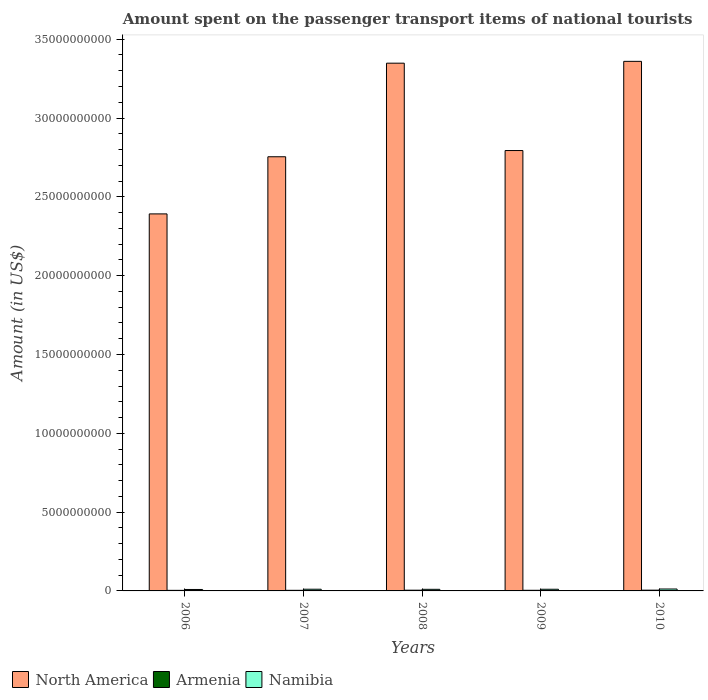How many groups of bars are there?
Provide a short and direct response. 5. Are the number of bars per tick equal to the number of legend labels?
Ensure brevity in your answer.  Yes. What is the amount spent on the passenger transport items of national tourists in Armenia in 2007?
Ensure brevity in your answer.  3.80e+07. Across all years, what is the maximum amount spent on the passenger transport items of national tourists in North America?
Your response must be concise. 3.36e+1. Across all years, what is the minimum amount spent on the passenger transport items of national tourists in Namibia?
Your answer should be compact. 9.20e+07. In which year was the amount spent on the passenger transport items of national tourists in North America maximum?
Your answer should be very brief. 2010. In which year was the amount spent on the passenger transport items of national tourists in Armenia minimum?
Ensure brevity in your answer.  2006. What is the total amount spent on the passenger transport items of national tourists in Armenia in the graph?
Your response must be concise. 2.08e+08. What is the difference between the amount spent on the passenger transport items of national tourists in Namibia in 2007 and that in 2008?
Provide a short and direct response. 6.00e+06. What is the difference between the amount spent on the passenger transport items of national tourists in Armenia in 2008 and the amount spent on the passenger transport items of national tourists in North America in 2010?
Ensure brevity in your answer.  -3.36e+1. What is the average amount spent on the passenger transport items of national tourists in Armenia per year?
Ensure brevity in your answer.  4.16e+07. In the year 2006, what is the difference between the amount spent on the passenger transport items of national tourists in North America and amount spent on the passenger transport items of national tourists in Armenia?
Give a very brief answer. 2.39e+1. In how many years, is the amount spent on the passenger transport items of national tourists in Armenia greater than 6000000000 US$?
Offer a terse response. 0. What is the ratio of the amount spent on the passenger transport items of national tourists in Armenia in 2008 to that in 2009?
Your answer should be compact. 1.15. Is the amount spent on the passenger transport items of national tourists in Armenia in 2006 less than that in 2009?
Keep it short and to the point. Yes. Is the difference between the amount spent on the passenger transport items of national tourists in North America in 2008 and 2009 greater than the difference between the amount spent on the passenger transport items of national tourists in Armenia in 2008 and 2009?
Your response must be concise. Yes. What is the difference between the highest and the second highest amount spent on the passenger transport items of national tourists in Armenia?
Offer a very short reply. 2.00e+06. What is the difference between the highest and the lowest amount spent on the passenger transport items of national tourists in North America?
Provide a short and direct response. 9.68e+09. In how many years, is the amount spent on the passenger transport items of national tourists in Namibia greater than the average amount spent on the passenger transport items of national tourists in Namibia taken over all years?
Your answer should be compact. 3. What does the 2nd bar from the left in 2008 represents?
Make the answer very short. Armenia. What does the 1st bar from the right in 2006 represents?
Give a very brief answer. Namibia. Is it the case that in every year, the sum of the amount spent on the passenger transport items of national tourists in Namibia and amount spent on the passenger transport items of national tourists in North America is greater than the amount spent on the passenger transport items of national tourists in Armenia?
Offer a very short reply. Yes. How many years are there in the graph?
Your answer should be compact. 5. Does the graph contain any zero values?
Your response must be concise. No. Where does the legend appear in the graph?
Give a very brief answer. Bottom left. How are the legend labels stacked?
Give a very brief answer. Horizontal. What is the title of the graph?
Your answer should be compact. Amount spent on the passenger transport items of national tourists. Does "Hong Kong" appear as one of the legend labels in the graph?
Your answer should be very brief. No. What is the label or title of the X-axis?
Offer a terse response. Years. What is the Amount (in US$) in North America in 2006?
Provide a short and direct response. 2.39e+1. What is the Amount (in US$) of Armenia in 2006?
Your response must be concise. 3.60e+07. What is the Amount (in US$) of Namibia in 2006?
Your response must be concise. 9.20e+07. What is the Amount (in US$) in North America in 2007?
Offer a terse response. 2.75e+1. What is the Amount (in US$) in Armenia in 2007?
Make the answer very short. 3.80e+07. What is the Amount (in US$) in Namibia in 2007?
Provide a succinct answer. 1.08e+08. What is the Amount (in US$) in North America in 2008?
Your answer should be compact. 3.35e+1. What is the Amount (in US$) in Armenia in 2008?
Your response must be concise. 4.60e+07. What is the Amount (in US$) in Namibia in 2008?
Offer a very short reply. 1.02e+08. What is the Amount (in US$) in North America in 2009?
Your answer should be very brief. 2.79e+1. What is the Amount (in US$) of Armenia in 2009?
Make the answer very short. 4.00e+07. What is the Amount (in US$) of Namibia in 2009?
Keep it short and to the point. 1.06e+08. What is the Amount (in US$) in North America in 2010?
Your answer should be compact. 3.36e+1. What is the Amount (in US$) of Armenia in 2010?
Make the answer very short. 4.80e+07. What is the Amount (in US$) in Namibia in 2010?
Your answer should be very brief. 1.21e+08. Across all years, what is the maximum Amount (in US$) of North America?
Your answer should be very brief. 3.36e+1. Across all years, what is the maximum Amount (in US$) in Armenia?
Your answer should be compact. 4.80e+07. Across all years, what is the maximum Amount (in US$) in Namibia?
Your answer should be very brief. 1.21e+08. Across all years, what is the minimum Amount (in US$) of North America?
Give a very brief answer. 2.39e+1. Across all years, what is the minimum Amount (in US$) of Armenia?
Your answer should be very brief. 3.60e+07. Across all years, what is the minimum Amount (in US$) of Namibia?
Your response must be concise. 9.20e+07. What is the total Amount (in US$) in North America in the graph?
Ensure brevity in your answer.  1.46e+11. What is the total Amount (in US$) in Armenia in the graph?
Provide a succinct answer. 2.08e+08. What is the total Amount (in US$) in Namibia in the graph?
Keep it short and to the point. 5.29e+08. What is the difference between the Amount (in US$) in North America in 2006 and that in 2007?
Your answer should be compact. -3.63e+09. What is the difference between the Amount (in US$) of Armenia in 2006 and that in 2007?
Your answer should be very brief. -2.00e+06. What is the difference between the Amount (in US$) in Namibia in 2006 and that in 2007?
Your answer should be compact. -1.60e+07. What is the difference between the Amount (in US$) in North America in 2006 and that in 2008?
Offer a very short reply. -9.56e+09. What is the difference between the Amount (in US$) in Armenia in 2006 and that in 2008?
Offer a very short reply. -1.00e+07. What is the difference between the Amount (in US$) in Namibia in 2006 and that in 2008?
Give a very brief answer. -1.00e+07. What is the difference between the Amount (in US$) in North America in 2006 and that in 2009?
Keep it short and to the point. -4.02e+09. What is the difference between the Amount (in US$) of Namibia in 2006 and that in 2009?
Provide a short and direct response. -1.40e+07. What is the difference between the Amount (in US$) of North America in 2006 and that in 2010?
Offer a very short reply. -9.68e+09. What is the difference between the Amount (in US$) in Armenia in 2006 and that in 2010?
Your answer should be very brief. -1.20e+07. What is the difference between the Amount (in US$) in Namibia in 2006 and that in 2010?
Give a very brief answer. -2.90e+07. What is the difference between the Amount (in US$) in North America in 2007 and that in 2008?
Keep it short and to the point. -5.94e+09. What is the difference between the Amount (in US$) of Armenia in 2007 and that in 2008?
Your answer should be compact. -8.00e+06. What is the difference between the Amount (in US$) of North America in 2007 and that in 2009?
Your answer should be very brief. -3.94e+08. What is the difference between the Amount (in US$) of Namibia in 2007 and that in 2009?
Provide a short and direct response. 2.00e+06. What is the difference between the Amount (in US$) in North America in 2007 and that in 2010?
Provide a succinct answer. -6.05e+09. What is the difference between the Amount (in US$) in Armenia in 2007 and that in 2010?
Give a very brief answer. -1.00e+07. What is the difference between the Amount (in US$) in Namibia in 2007 and that in 2010?
Give a very brief answer. -1.30e+07. What is the difference between the Amount (in US$) of North America in 2008 and that in 2009?
Your answer should be compact. 5.54e+09. What is the difference between the Amount (in US$) in North America in 2008 and that in 2010?
Offer a very short reply. -1.16e+08. What is the difference between the Amount (in US$) in Armenia in 2008 and that in 2010?
Offer a terse response. -2.00e+06. What is the difference between the Amount (in US$) in Namibia in 2008 and that in 2010?
Your answer should be compact. -1.90e+07. What is the difference between the Amount (in US$) in North America in 2009 and that in 2010?
Provide a short and direct response. -5.66e+09. What is the difference between the Amount (in US$) in Armenia in 2009 and that in 2010?
Keep it short and to the point. -8.00e+06. What is the difference between the Amount (in US$) of Namibia in 2009 and that in 2010?
Make the answer very short. -1.50e+07. What is the difference between the Amount (in US$) of North America in 2006 and the Amount (in US$) of Armenia in 2007?
Provide a succinct answer. 2.39e+1. What is the difference between the Amount (in US$) in North America in 2006 and the Amount (in US$) in Namibia in 2007?
Make the answer very short. 2.38e+1. What is the difference between the Amount (in US$) in Armenia in 2006 and the Amount (in US$) in Namibia in 2007?
Offer a terse response. -7.20e+07. What is the difference between the Amount (in US$) in North America in 2006 and the Amount (in US$) in Armenia in 2008?
Keep it short and to the point. 2.39e+1. What is the difference between the Amount (in US$) in North America in 2006 and the Amount (in US$) in Namibia in 2008?
Make the answer very short. 2.38e+1. What is the difference between the Amount (in US$) in Armenia in 2006 and the Amount (in US$) in Namibia in 2008?
Your answer should be compact. -6.60e+07. What is the difference between the Amount (in US$) of North America in 2006 and the Amount (in US$) of Armenia in 2009?
Give a very brief answer. 2.39e+1. What is the difference between the Amount (in US$) of North America in 2006 and the Amount (in US$) of Namibia in 2009?
Ensure brevity in your answer.  2.38e+1. What is the difference between the Amount (in US$) in Armenia in 2006 and the Amount (in US$) in Namibia in 2009?
Make the answer very short. -7.00e+07. What is the difference between the Amount (in US$) in North America in 2006 and the Amount (in US$) in Armenia in 2010?
Provide a short and direct response. 2.39e+1. What is the difference between the Amount (in US$) of North America in 2006 and the Amount (in US$) of Namibia in 2010?
Give a very brief answer. 2.38e+1. What is the difference between the Amount (in US$) of Armenia in 2006 and the Amount (in US$) of Namibia in 2010?
Your response must be concise. -8.50e+07. What is the difference between the Amount (in US$) of North America in 2007 and the Amount (in US$) of Armenia in 2008?
Make the answer very short. 2.75e+1. What is the difference between the Amount (in US$) in North America in 2007 and the Amount (in US$) in Namibia in 2008?
Provide a short and direct response. 2.74e+1. What is the difference between the Amount (in US$) of Armenia in 2007 and the Amount (in US$) of Namibia in 2008?
Give a very brief answer. -6.40e+07. What is the difference between the Amount (in US$) in North America in 2007 and the Amount (in US$) in Armenia in 2009?
Offer a very short reply. 2.75e+1. What is the difference between the Amount (in US$) of North America in 2007 and the Amount (in US$) of Namibia in 2009?
Your response must be concise. 2.74e+1. What is the difference between the Amount (in US$) in Armenia in 2007 and the Amount (in US$) in Namibia in 2009?
Make the answer very short. -6.80e+07. What is the difference between the Amount (in US$) in North America in 2007 and the Amount (in US$) in Armenia in 2010?
Provide a succinct answer. 2.75e+1. What is the difference between the Amount (in US$) of North America in 2007 and the Amount (in US$) of Namibia in 2010?
Make the answer very short. 2.74e+1. What is the difference between the Amount (in US$) of Armenia in 2007 and the Amount (in US$) of Namibia in 2010?
Your answer should be very brief. -8.30e+07. What is the difference between the Amount (in US$) of North America in 2008 and the Amount (in US$) of Armenia in 2009?
Ensure brevity in your answer.  3.34e+1. What is the difference between the Amount (in US$) in North America in 2008 and the Amount (in US$) in Namibia in 2009?
Offer a terse response. 3.34e+1. What is the difference between the Amount (in US$) in Armenia in 2008 and the Amount (in US$) in Namibia in 2009?
Ensure brevity in your answer.  -6.00e+07. What is the difference between the Amount (in US$) of North America in 2008 and the Amount (in US$) of Armenia in 2010?
Offer a terse response. 3.34e+1. What is the difference between the Amount (in US$) in North America in 2008 and the Amount (in US$) in Namibia in 2010?
Ensure brevity in your answer.  3.34e+1. What is the difference between the Amount (in US$) of Armenia in 2008 and the Amount (in US$) of Namibia in 2010?
Offer a terse response. -7.50e+07. What is the difference between the Amount (in US$) of North America in 2009 and the Amount (in US$) of Armenia in 2010?
Your answer should be compact. 2.79e+1. What is the difference between the Amount (in US$) of North America in 2009 and the Amount (in US$) of Namibia in 2010?
Your response must be concise. 2.78e+1. What is the difference between the Amount (in US$) in Armenia in 2009 and the Amount (in US$) in Namibia in 2010?
Your answer should be compact. -8.10e+07. What is the average Amount (in US$) in North America per year?
Make the answer very short. 2.93e+1. What is the average Amount (in US$) in Armenia per year?
Your answer should be very brief. 4.16e+07. What is the average Amount (in US$) of Namibia per year?
Your answer should be compact. 1.06e+08. In the year 2006, what is the difference between the Amount (in US$) of North America and Amount (in US$) of Armenia?
Your answer should be compact. 2.39e+1. In the year 2006, what is the difference between the Amount (in US$) in North America and Amount (in US$) in Namibia?
Keep it short and to the point. 2.38e+1. In the year 2006, what is the difference between the Amount (in US$) of Armenia and Amount (in US$) of Namibia?
Give a very brief answer. -5.60e+07. In the year 2007, what is the difference between the Amount (in US$) of North America and Amount (in US$) of Armenia?
Your response must be concise. 2.75e+1. In the year 2007, what is the difference between the Amount (in US$) of North America and Amount (in US$) of Namibia?
Give a very brief answer. 2.74e+1. In the year 2007, what is the difference between the Amount (in US$) in Armenia and Amount (in US$) in Namibia?
Give a very brief answer. -7.00e+07. In the year 2008, what is the difference between the Amount (in US$) of North America and Amount (in US$) of Armenia?
Your response must be concise. 3.34e+1. In the year 2008, what is the difference between the Amount (in US$) of North America and Amount (in US$) of Namibia?
Offer a terse response. 3.34e+1. In the year 2008, what is the difference between the Amount (in US$) of Armenia and Amount (in US$) of Namibia?
Make the answer very short. -5.60e+07. In the year 2009, what is the difference between the Amount (in US$) in North America and Amount (in US$) in Armenia?
Provide a succinct answer. 2.79e+1. In the year 2009, what is the difference between the Amount (in US$) in North America and Amount (in US$) in Namibia?
Provide a short and direct response. 2.78e+1. In the year 2009, what is the difference between the Amount (in US$) of Armenia and Amount (in US$) of Namibia?
Keep it short and to the point. -6.60e+07. In the year 2010, what is the difference between the Amount (in US$) of North America and Amount (in US$) of Armenia?
Ensure brevity in your answer.  3.35e+1. In the year 2010, what is the difference between the Amount (in US$) in North America and Amount (in US$) in Namibia?
Keep it short and to the point. 3.35e+1. In the year 2010, what is the difference between the Amount (in US$) of Armenia and Amount (in US$) of Namibia?
Make the answer very short. -7.30e+07. What is the ratio of the Amount (in US$) in North America in 2006 to that in 2007?
Make the answer very short. 0.87. What is the ratio of the Amount (in US$) in Armenia in 2006 to that in 2007?
Ensure brevity in your answer.  0.95. What is the ratio of the Amount (in US$) of Namibia in 2006 to that in 2007?
Your answer should be compact. 0.85. What is the ratio of the Amount (in US$) in North America in 2006 to that in 2008?
Ensure brevity in your answer.  0.71. What is the ratio of the Amount (in US$) in Armenia in 2006 to that in 2008?
Offer a terse response. 0.78. What is the ratio of the Amount (in US$) in Namibia in 2006 to that in 2008?
Your answer should be very brief. 0.9. What is the ratio of the Amount (in US$) of North America in 2006 to that in 2009?
Your response must be concise. 0.86. What is the ratio of the Amount (in US$) of Armenia in 2006 to that in 2009?
Provide a succinct answer. 0.9. What is the ratio of the Amount (in US$) of Namibia in 2006 to that in 2009?
Ensure brevity in your answer.  0.87. What is the ratio of the Amount (in US$) of North America in 2006 to that in 2010?
Make the answer very short. 0.71. What is the ratio of the Amount (in US$) of Namibia in 2006 to that in 2010?
Offer a very short reply. 0.76. What is the ratio of the Amount (in US$) in North America in 2007 to that in 2008?
Make the answer very short. 0.82. What is the ratio of the Amount (in US$) of Armenia in 2007 to that in 2008?
Give a very brief answer. 0.83. What is the ratio of the Amount (in US$) in Namibia in 2007 to that in 2008?
Your response must be concise. 1.06. What is the ratio of the Amount (in US$) in North America in 2007 to that in 2009?
Your answer should be very brief. 0.99. What is the ratio of the Amount (in US$) in Armenia in 2007 to that in 2009?
Offer a very short reply. 0.95. What is the ratio of the Amount (in US$) in Namibia in 2007 to that in 2009?
Your answer should be very brief. 1.02. What is the ratio of the Amount (in US$) in North America in 2007 to that in 2010?
Provide a succinct answer. 0.82. What is the ratio of the Amount (in US$) in Armenia in 2007 to that in 2010?
Your answer should be very brief. 0.79. What is the ratio of the Amount (in US$) in Namibia in 2007 to that in 2010?
Ensure brevity in your answer.  0.89. What is the ratio of the Amount (in US$) of North America in 2008 to that in 2009?
Your answer should be compact. 1.2. What is the ratio of the Amount (in US$) in Armenia in 2008 to that in 2009?
Provide a short and direct response. 1.15. What is the ratio of the Amount (in US$) of Namibia in 2008 to that in 2009?
Ensure brevity in your answer.  0.96. What is the ratio of the Amount (in US$) in North America in 2008 to that in 2010?
Your response must be concise. 1. What is the ratio of the Amount (in US$) of Namibia in 2008 to that in 2010?
Offer a very short reply. 0.84. What is the ratio of the Amount (in US$) in North America in 2009 to that in 2010?
Your answer should be compact. 0.83. What is the ratio of the Amount (in US$) in Namibia in 2009 to that in 2010?
Offer a terse response. 0.88. What is the difference between the highest and the second highest Amount (in US$) of North America?
Provide a succinct answer. 1.16e+08. What is the difference between the highest and the second highest Amount (in US$) in Armenia?
Make the answer very short. 2.00e+06. What is the difference between the highest and the second highest Amount (in US$) in Namibia?
Make the answer very short. 1.30e+07. What is the difference between the highest and the lowest Amount (in US$) in North America?
Keep it short and to the point. 9.68e+09. What is the difference between the highest and the lowest Amount (in US$) of Armenia?
Your response must be concise. 1.20e+07. What is the difference between the highest and the lowest Amount (in US$) in Namibia?
Make the answer very short. 2.90e+07. 